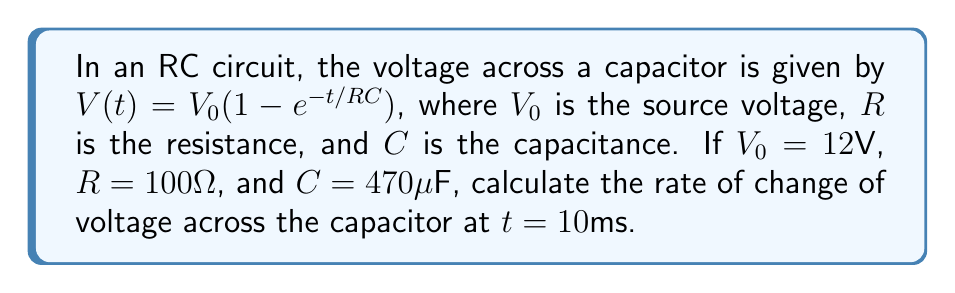Can you answer this question? To find the rate of change of voltage, we need to differentiate $V(t)$ with respect to time:

1) First, let's calculate the time constant $\tau = RC$:
   $\tau = 100\Omega \cdot 470\mu F = 47ms$

2) Now, we can rewrite the voltage equation:
   $V(t) = 12(1 - e^{-t/47ms})$

3) Differentiate $V(t)$ with respect to $t$:
   $$\frac{dV}{dt} = 12 \cdot \frac{1}{47ms} \cdot e^{-t/47ms}$$

4) Simplify:
   $$\frac{dV}{dt} = \frac{12}{47ms} \cdot e^{-t/47ms}$$

5) Calculate the rate of change at $t = 10ms$:
   $$\frac{dV}{dt}\Big|_{t=10ms} = \frac{12}{47ms} \cdot e^{-10ms/47ms}$$

6) Evaluate:
   $$\frac{dV}{dt}\Big|_{t=10ms} = 255.32 \cdot e^{-0.2128} = 203.36 V/s$$

Therefore, the rate of change of voltage across the capacitor at $t = 10ms$ is approximately 203.36 V/s.
Answer: $203.36 V/s$ 